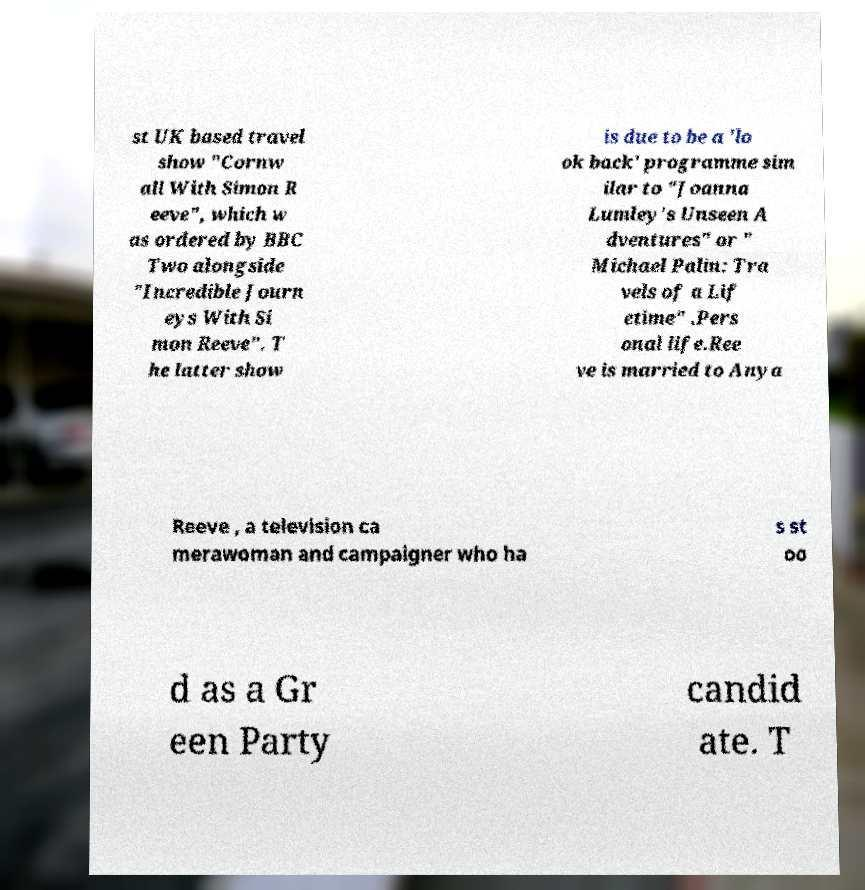There's text embedded in this image that I need extracted. Can you transcribe it verbatim? st UK based travel show "Cornw all With Simon R eeve", which w as ordered by BBC Two alongside "Incredible Journ eys With Si mon Reeve". T he latter show is due to be a 'lo ok back' programme sim ilar to "Joanna Lumley's Unseen A dventures" or " Michael Palin: Tra vels of a Lif etime" .Pers onal life.Ree ve is married to Anya Reeve , a television ca merawoman and campaigner who ha s st oo d as a Gr een Party candid ate. T 